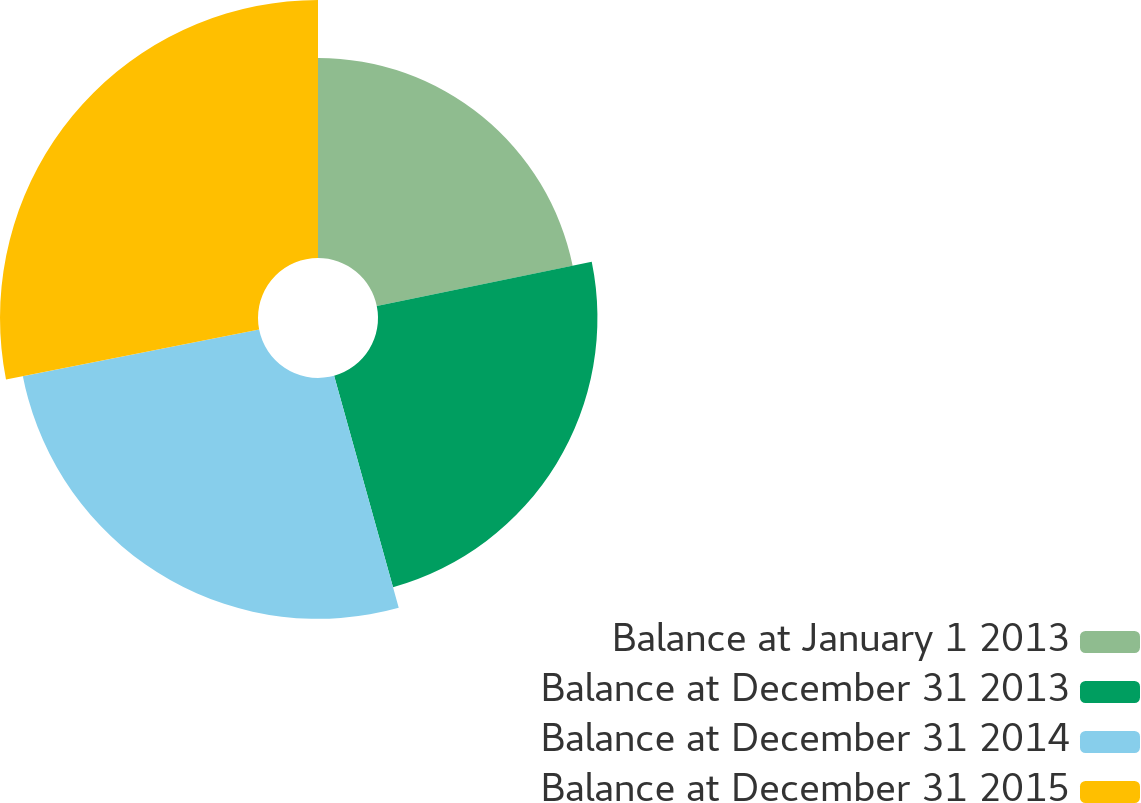Convert chart to OTSL. <chart><loc_0><loc_0><loc_500><loc_500><pie_chart><fcel>Balance at January 1 2013<fcel>Balance at December 31 2013<fcel>Balance at December 31 2014<fcel>Balance at December 31 2015<nl><fcel>21.78%<fcel>23.9%<fcel>26.23%<fcel>28.1%<nl></chart> 